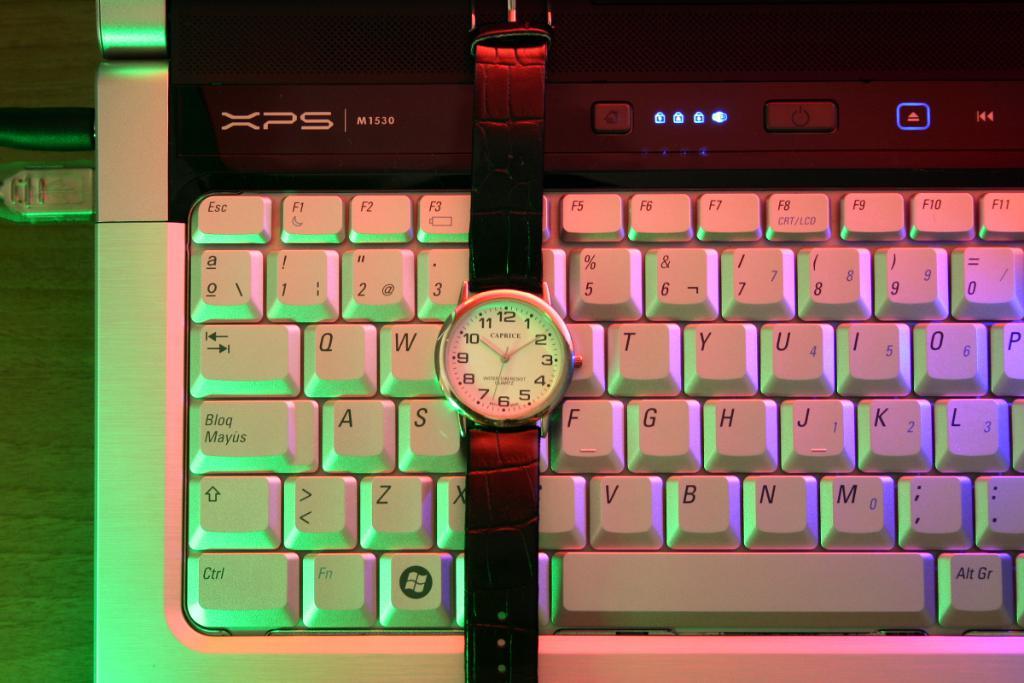What brand of watch is this?
Make the answer very short. Caprice. What three letters are written at the upper left of the keyboard?
Provide a succinct answer. Xps. 